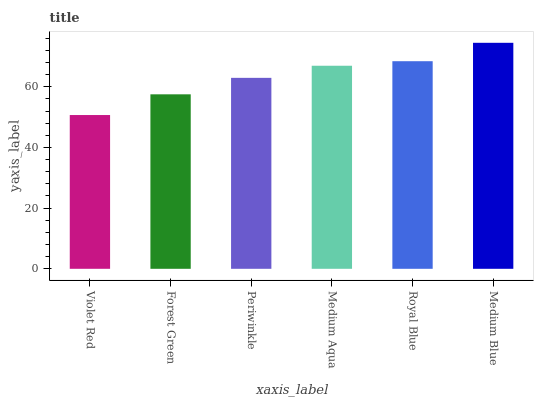Is Violet Red the minimum?
Answer yes or no. Yes. Is Medium Blue the maximum?
Answer yes or no. Yes. Is Forest Green the minimum?
Answer yes or no. No. Is Forest Green the maximum?
Answer yes or no. No. Is Forest Green greater than Violet Red?
Answer yes or no. Yes. Is Violet Red less than Forest Green?
Answer yes or no. Yes. Is Violet Red greater than Forest Green?
Answer yes or no. No. Is Forest Green less than Violet Red?
Answer yes or no. No. Is Medium Aqua the high median?
Answer yes or no. Yes. Is Periwinkle the low median?
Answer yes or no. Yes. Is Forest Green the high median?
Answer yes or no. No. Is Medium Aqua the low median?
Answer yes or no. No. 